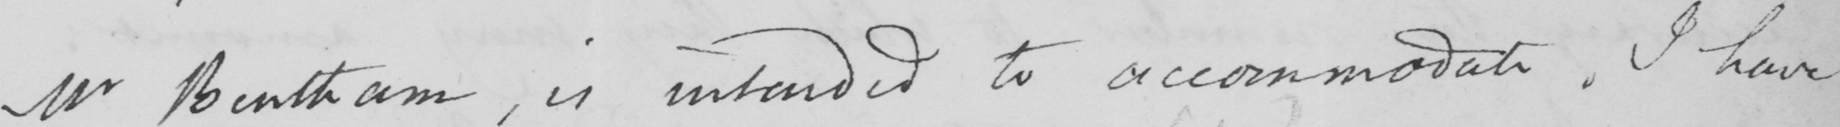Can you tell me what this handwritten text says? Mr Bentham, is intended to accommodate. I have 